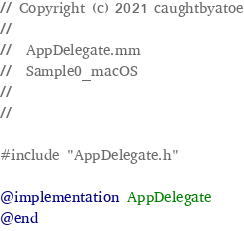Convert code to text. <code><loc_0><loc_0><loc_500><loc_500><_ObjectiveC_>// Copyright (c) 2021 caughtbyatoe
//
//  AppDelegate.mm
//  Sample0_macOS
//
//

#include "AppDelegate.h"

@implementation AppDelegate
@end
</code> 